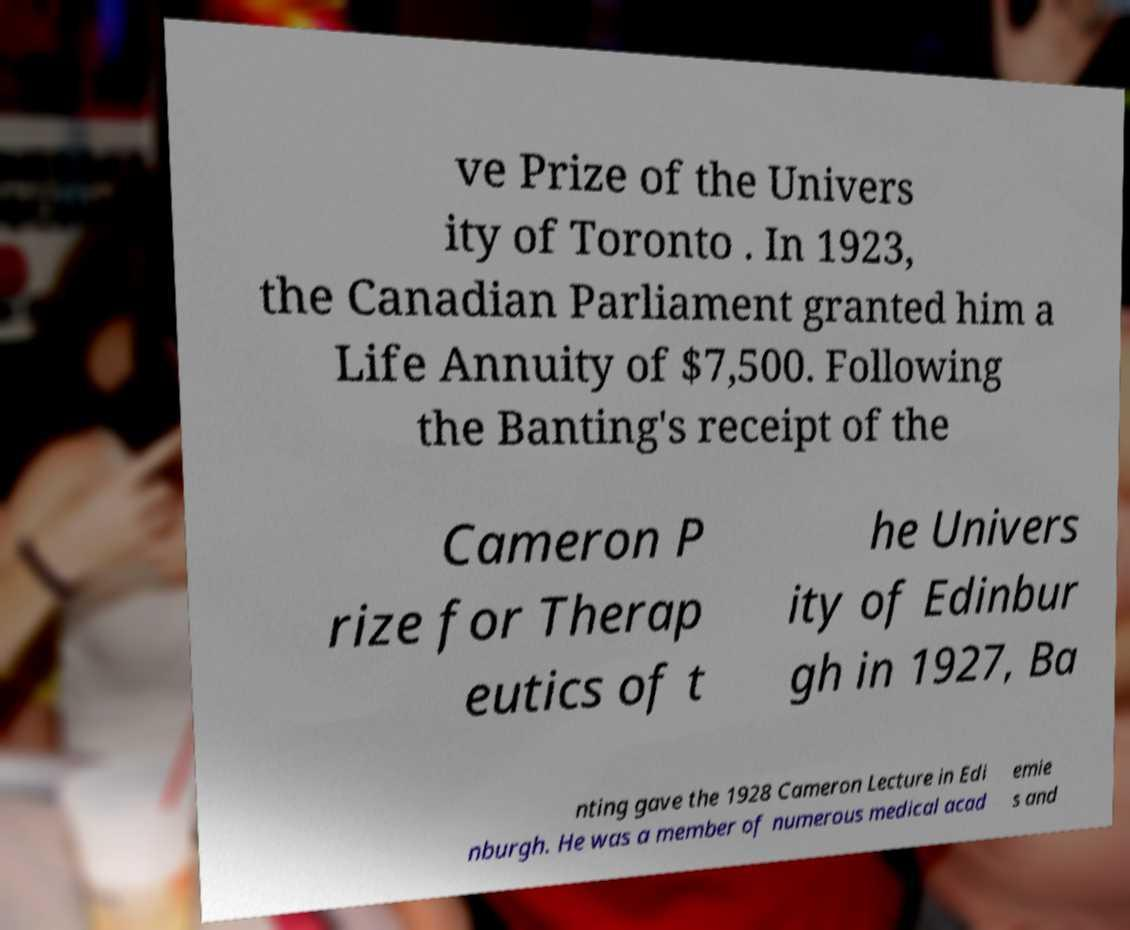Can you read and provide the text displayed in the image?This photo seems to have some interesting text. Can you extract and type it out for me? ve Prize of the Univers ity of Toronto . In 1923, the Canadian Parliament granted him a Life Annuity of $7,500. Following the Banting's receipt of the Cameron P rize for Therap eutics of t he Univers ity of Edinbur gh in 1927, Ba nting gave the 1928 Cameron Lecture in Edi nburgh. He was a member of numerous medical acad emie s and 